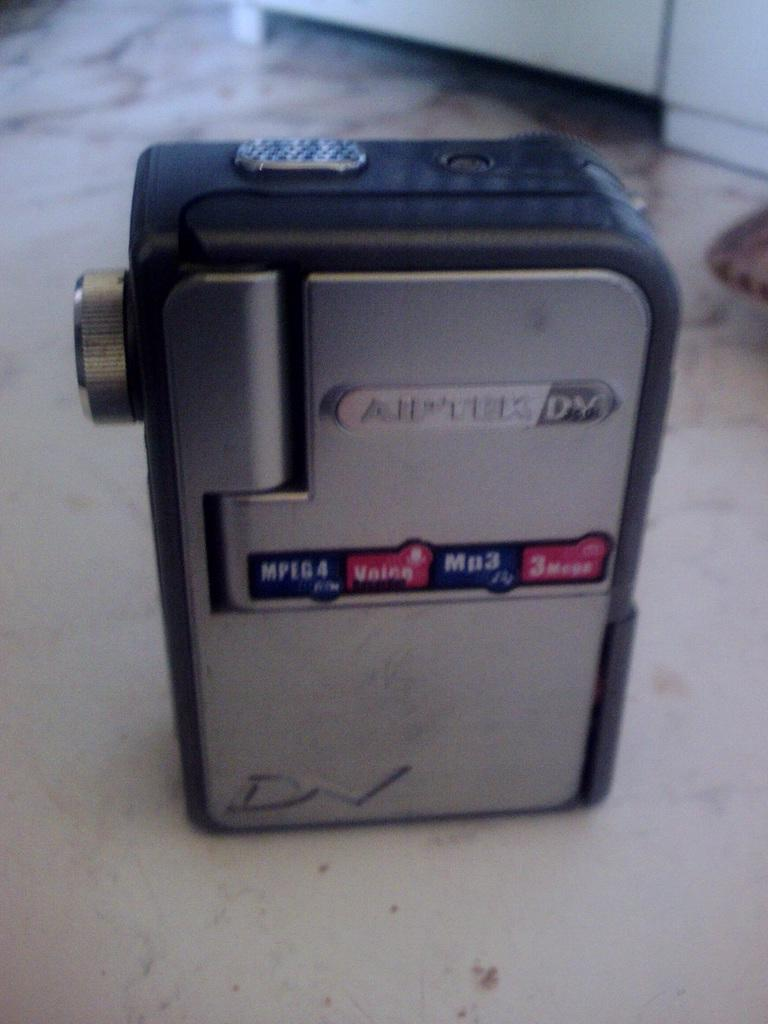What object is the main subject of the image? There is a gadget in the image. What colors are used in the design of the gadget? The gadget is in black and gray color. What can be seen on the surface of the gadget? There is text visible on the gadget. What type of device does the gadget resemble? The gadget resembles a video camera. What type of arch can be seen in the image? There is no arch present in the image; it features a gadget that resembles a video camera. How many people are participating in the protest in the image? There is no protest depicted in the image; it features a gadget that resembles a video camera. 